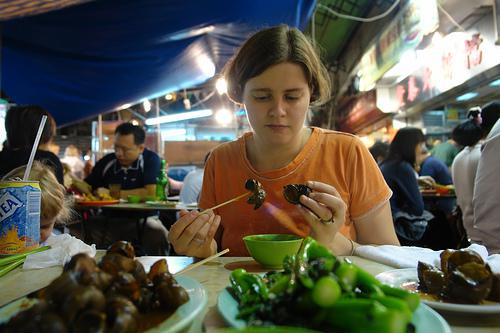Question: what kind of utensils are being used?
Choices:
A. Fork and knife.
B. Spoons.
C. Chop sticks.
D. Spatulas.
Answer with the letter. Answer: C Question: where is the straw?
Choices:
A. In the sippy cup.
B. In the tumbler.
C. In the tea.
D. In the coke.
Answer with the letter. Answer: C 